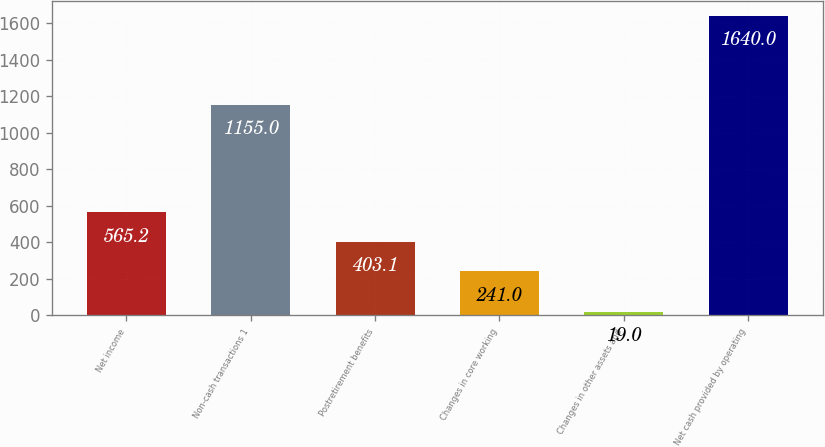Convert chart. <chart><loc_0><loc_0><loc_500><loc_500><bar_chart><fcel>Net income<fcel>Non-cash transactions 1<fcel>Postretirement benefits<fcel>Changes in core working<fcel>Changes in other assets and<fcel>Net cash provided by operating<nl><fcel>565.2<fcel>1155<fcel>403.1<fcel>241<fcel>19<fcel>1640<nl></chart> 